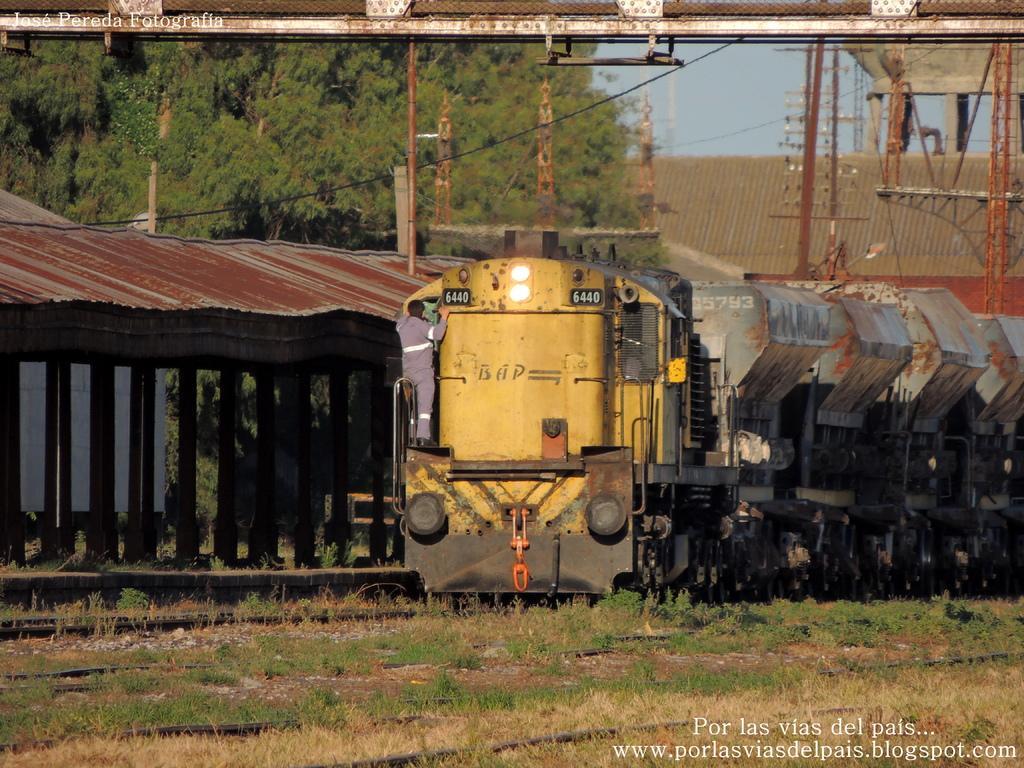Describe this image in one or two sentences. In the picture we can see train which is on the track, we can see a person standing on it and in the background of the picture there are some trees, iron rods, shed and top of the picture there is clear sky. 